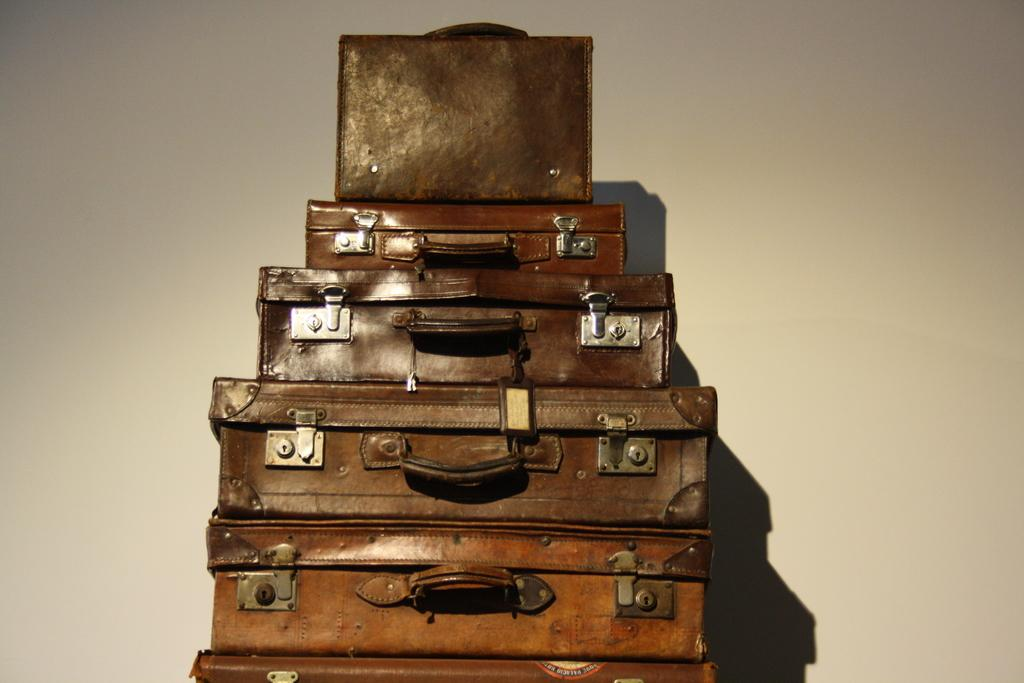What type of objects are present in the image? There are trunk boxes in the image. What is the color of the trunk boxes? The trunk boxes are brown in color. What is the color of the background in the image? The background of the image is white. How many goats can be seen playing with the trunk boxes in the image? There are no goats present in the image; it only features trunk boxes. 